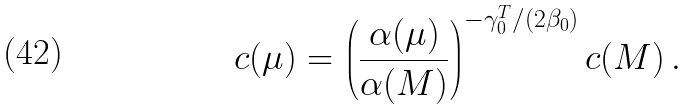<formula> <loc_0><loc_0><loc_500><loc_500>c ( \mu ) = \left ( \frac { \alpha ( \mu ) } { \alpha ( M ) } \right ) ^ { - \gamma ^ { T } _ { 0 } / ( 2 \beta _ { 0 } ) } c ( M ) \, .</formula> 